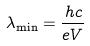Convert formula to latex. <formula><loc_0><loc_0><loc_500><loc_500>\lambda _ { \min } = \frac { h c } { e V }</formula> 